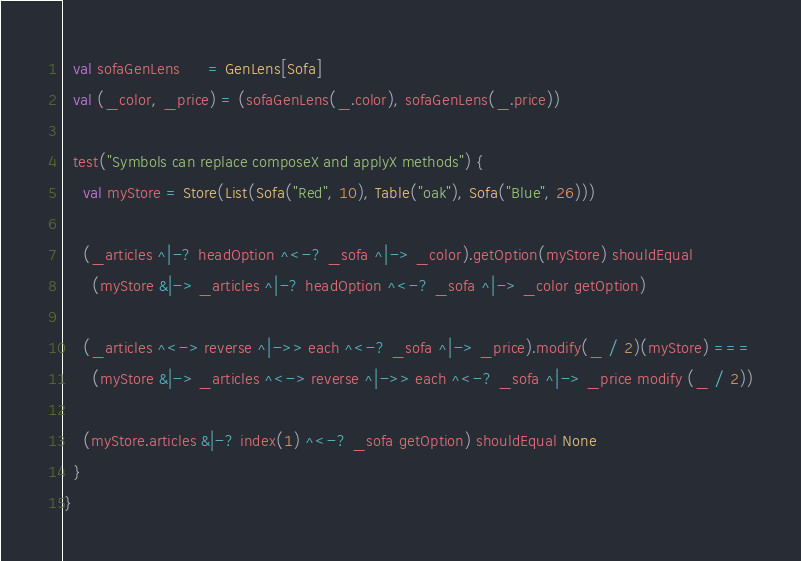Convert code to text. <code><loc_0><loc_0><loc_500><loc_500><_Scala_>  val sofaGenLens      = GenLens[Sofa]
  val (_color, _price) = (sofaGenLens(_.color), sofaGenLens(_.price))

  test("Symbols can replace composeX and applyX methods") {
    val myStore = Store(List(Sofa("Red", 10), Table("oak"), Sofa("Blue", 26)))

    (_articles ^|-? headOption ^<-? _sofa ^|-> _color).getOption(myStore) shouldEqual
      (myStore &|-> _articles ^|-? headOption ^<-? _sofa ^|-> _color getOption)

    (_articles ^<-> reverse ^|->> each ^<-? _sofa ^|-> _price).modify(_ / 2)(myStore) ===
      (myStore &|-> _articles ^<-> reverse ^|->> each ^<-? _sofa ^|-> _price modify (_ / 2))

    (myStore.articles &|-? index(1) ^<-? _sofa getOption) shouldEqual None
  }
}
</code> 